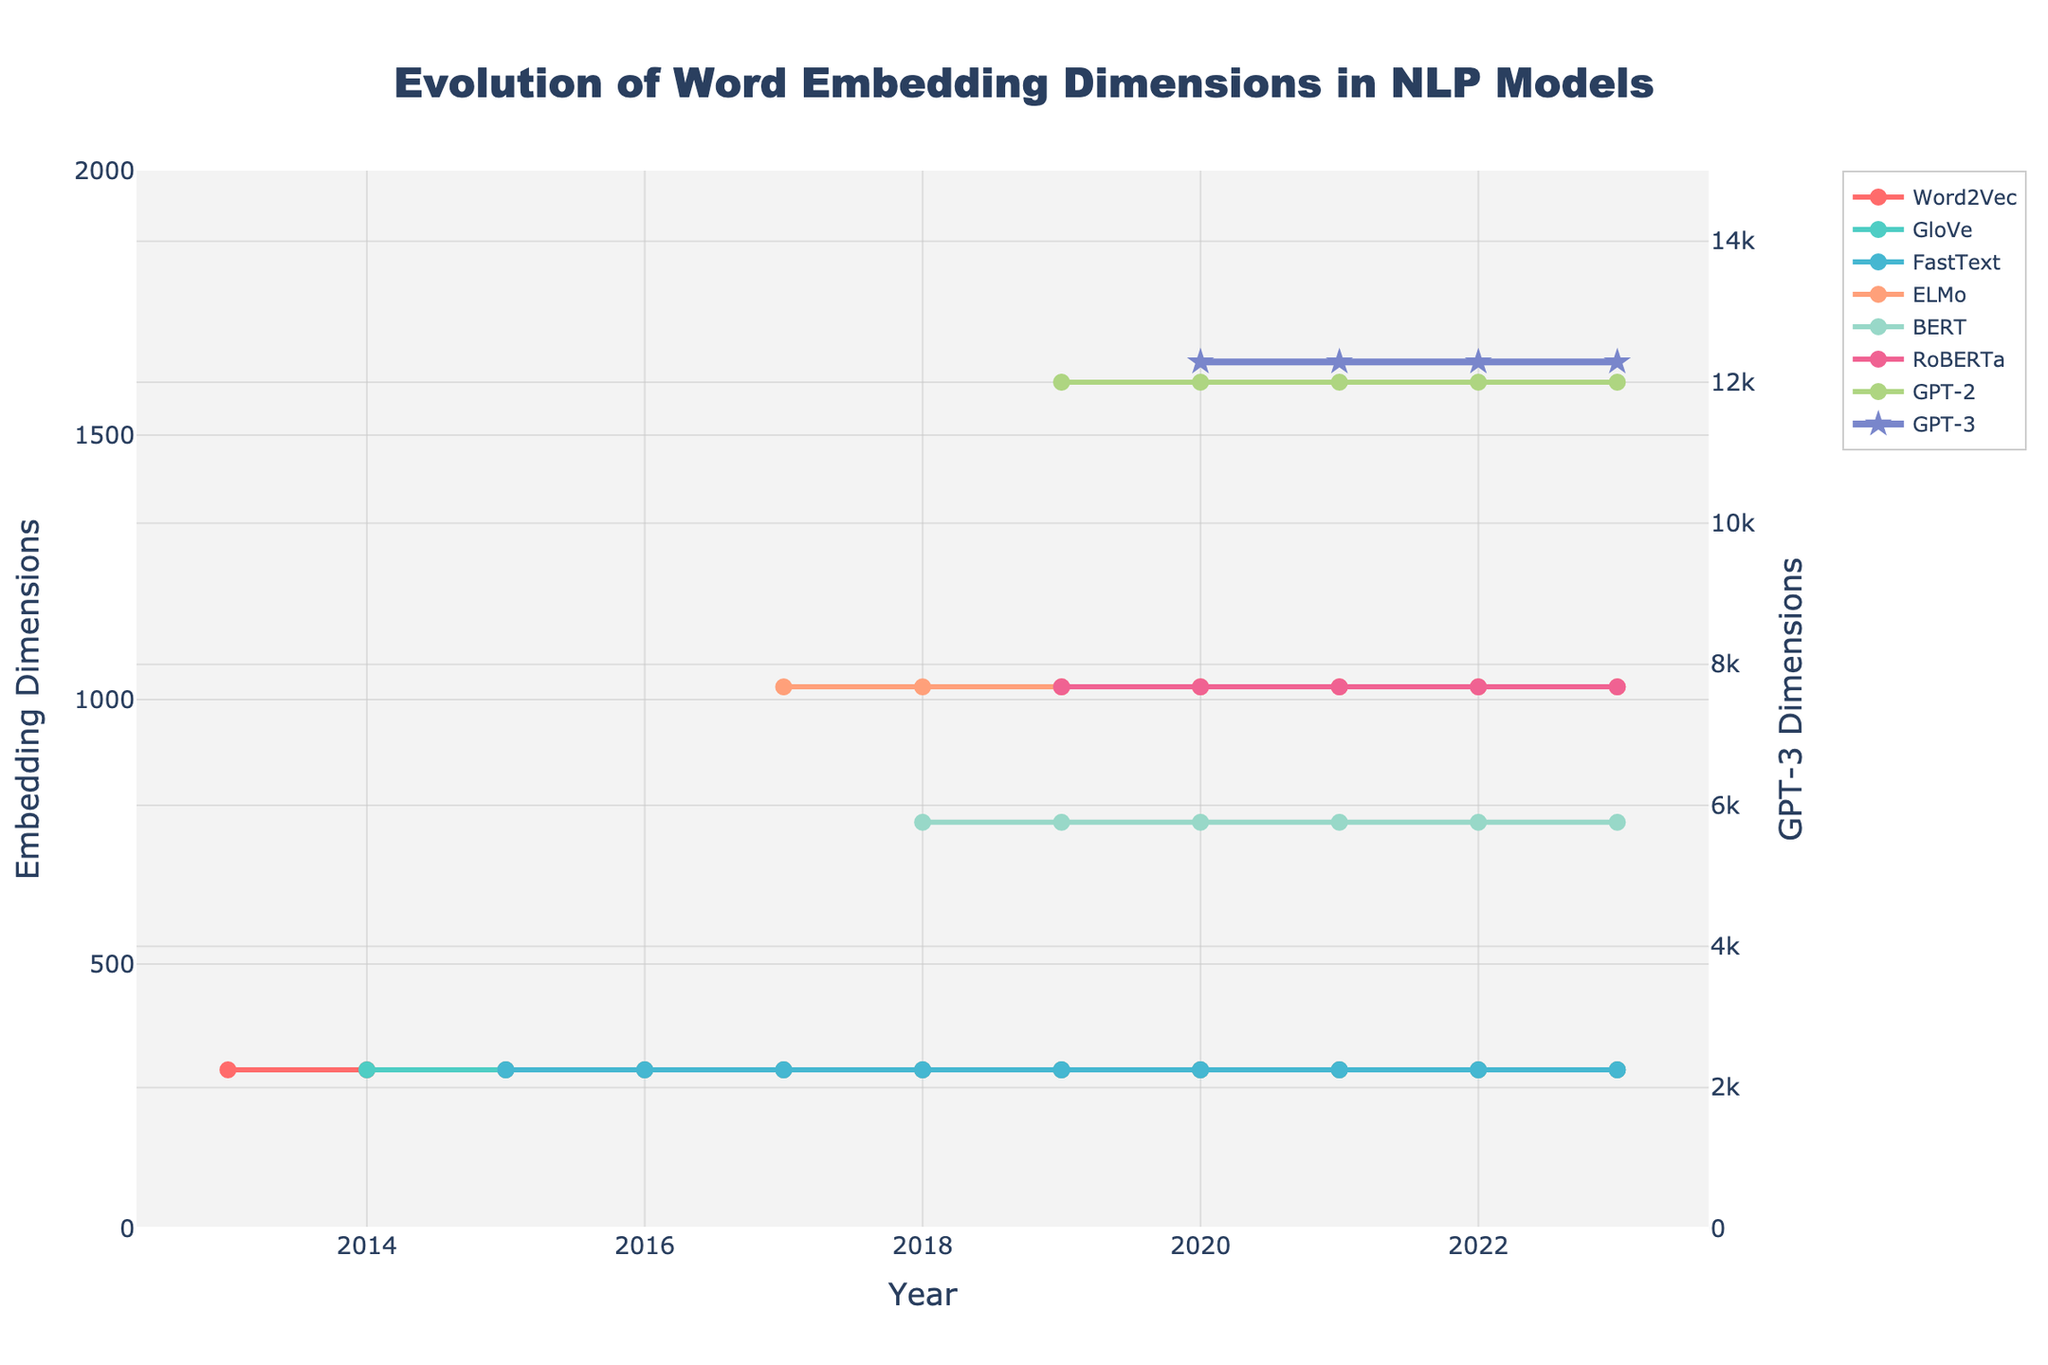What's the initial embedding dimension for Word2Vec? The initial embedding dimensions for Word2Vec in 2013 can be identified from the x-axis corresponding to Word2Vec's line on the graph.
Answer: 300 In which year did ELMo first appear, and what was its embedding dimension? Look at the trace for ELMo and find the first point on the graph where it is present. This year is when it first appears. The y-value at this point denotes its initial embedding dimension.
Answer: 2017, 1024 Which model shows a significant increase in embedding dimensions in 2020 compared to 2019? Examine the increase in embedding dimensions for all models from 2019 to 2020. The model with the most significant jump will be the one we are looking for.
Answer: GPT-3 What is the average embedding dimension of BERT from 2018 to 2023? Note the embedding dimensions of BERT for each year from 2018 to 2023. Add these values and then divide by the number of years (6) to get the average. BERT embedding dimensions = 768 (2018-2023) -> average = (768*6)/6
Answer: 768 Compare the embedding dimensions of FastText and RoBERTa in 2019. Which is higher and by how much? Look at the y-values for FastText and RoBERTa in 2019. Subtract the embedding dimension of FastText from RoBERTa. If RoBERTa's embedding dimension is higher, the difference will be positive. If not, the difference will be negative. RoBERTa dimension (1024) - FastText dimension (300)
Answer: RoBERTa by 724 What is the trend in embedding dimensions for GPT-2 from 2019 to 2023? Observe the y-values for GPT-2 from 2019 to 2023. Check whether these values are increasing, decreasing, or remaining constant over the years.
Answer: Constant at 1600 What are the colors associated with Word2Vec and GPT-3 on the plot? Identify the color used for Word2Vec and GPT-3 by looking at the respective lines on the plot. Word2Vec has a color similar to red, and GPT-3 will have a distinct color compared to others.
Answer: Word2Vec: Red, GPT-3: Purple What was the embedding dimension for the model introduced in 2020, showing a dimension of 12288? Look at the plot and find the model that has 12288 as the embedding dimension starting in 2020.
Answer: GPT-3 Which model's embedding dimension does not change over the given years, and what is that dimension? Look through the y-values for each model across all years. Identify the model with no change in its y-values.
Answer: Word2Vec (300) In 2023, how does RoBERTa's embedding dimension compare to ELMo's? Look at the y-values for both RoBERTa and ELMo in 2023. Compare these values directly by subtracting one from the other. RoBERTa (1024) - ELMo (1024)
Answer: Equal 